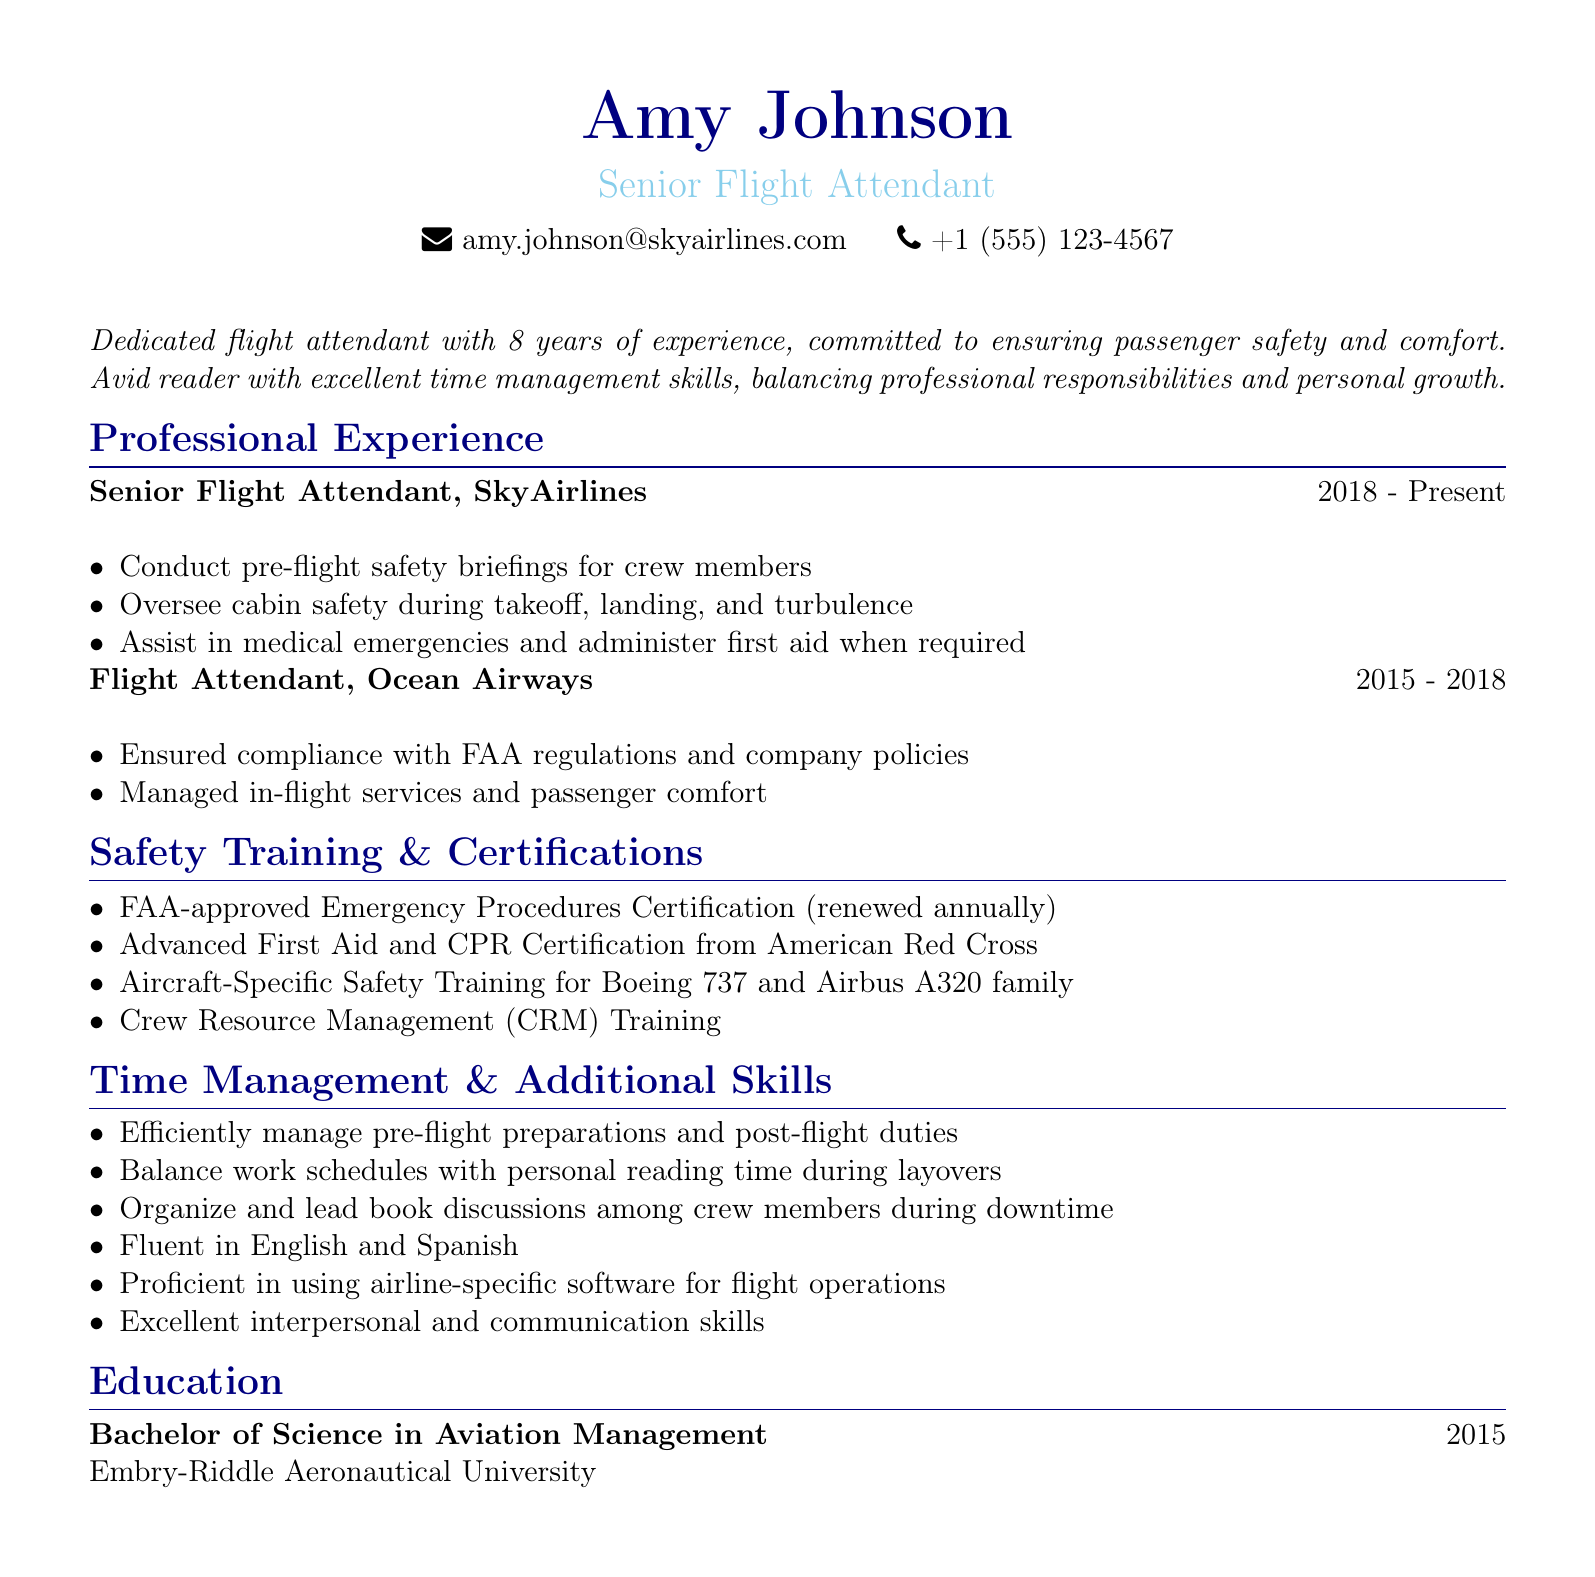What is the name of the flight attendant? The name is provided in the personal info section of the document.
Answer: Amy Johnson What is the current position of Amy Johnson? The document states her current professional position.
Answer: Senior Flight Attendant How many years of experience does Amy Johnson have? The summary section mentions her total years of experience in the field.
Answer: 8 years Which certifications does she hold for safety training? The safety training section lists her certifications.
Answer: FAA-approved Emergency Procedures Certification What skills has Amy developed related to time management? The time management section outlines her skills in balancing work and reading.
Answer: Balance work schedules with personal reading time during layovers Which languages is Amy fluent in? The additional skills section specifies the languages she speaks.
Answer: English and Spanish What degree does Amy hold? The education section of the document states her degree.
Answer: Bachelor of Science in Aviation Management Where did Amy complete her degree? The education section provides information about the institution.
Answer: Embry-Riddle Aeronautical University When did Amy start working at SkyAirlines? The professional experience section indicates the start date of her current position.
Answer: 2018 